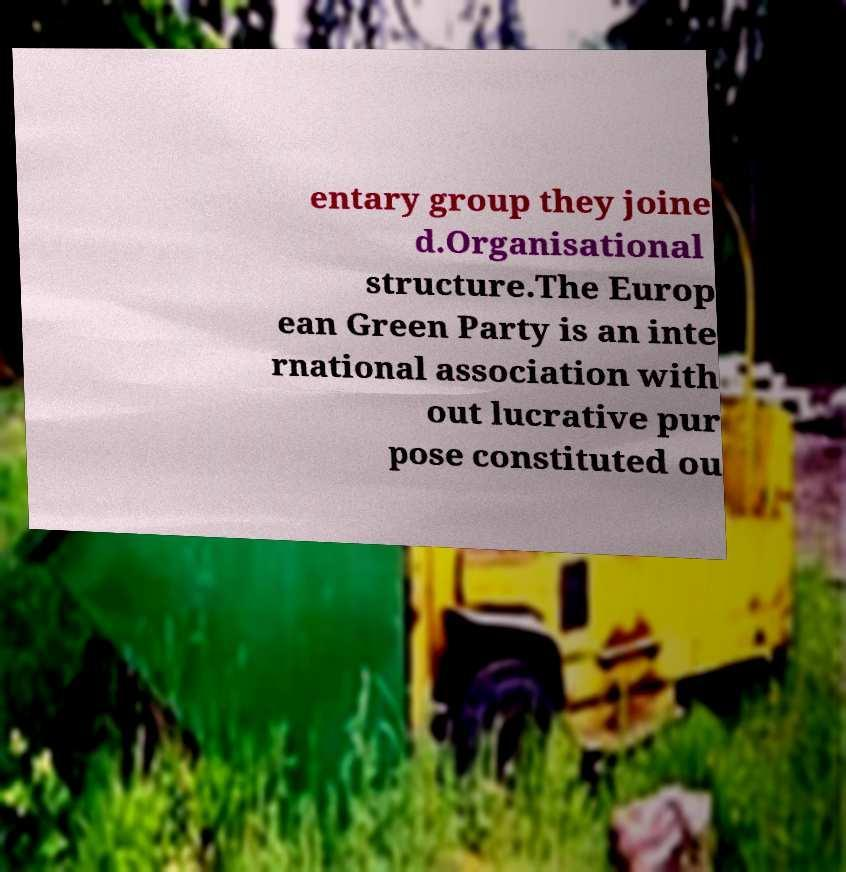I need the written content from this picture converted into text. Can you do that? entary group they joine d.Organisational structure.The Europ ean Green Party is an inte rnational association with out lucrative pur pose constituted ou 